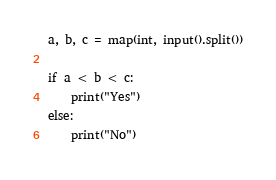Convert code to text. <code><loc_0><loc_0><loc_500><loc_500><_Python_>a, b, c = map(int, input().split())

if a < b < c:
    print("Yes")
else:
    print("No")
</code> 